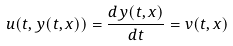Convert formula to latex. <formula><loc_0><loc_0><loc_500><loc_500>u ( t , y ( t , x ) ) = \frac { d y ( t , x ) } { d t } = v ( t , x )</formula> 